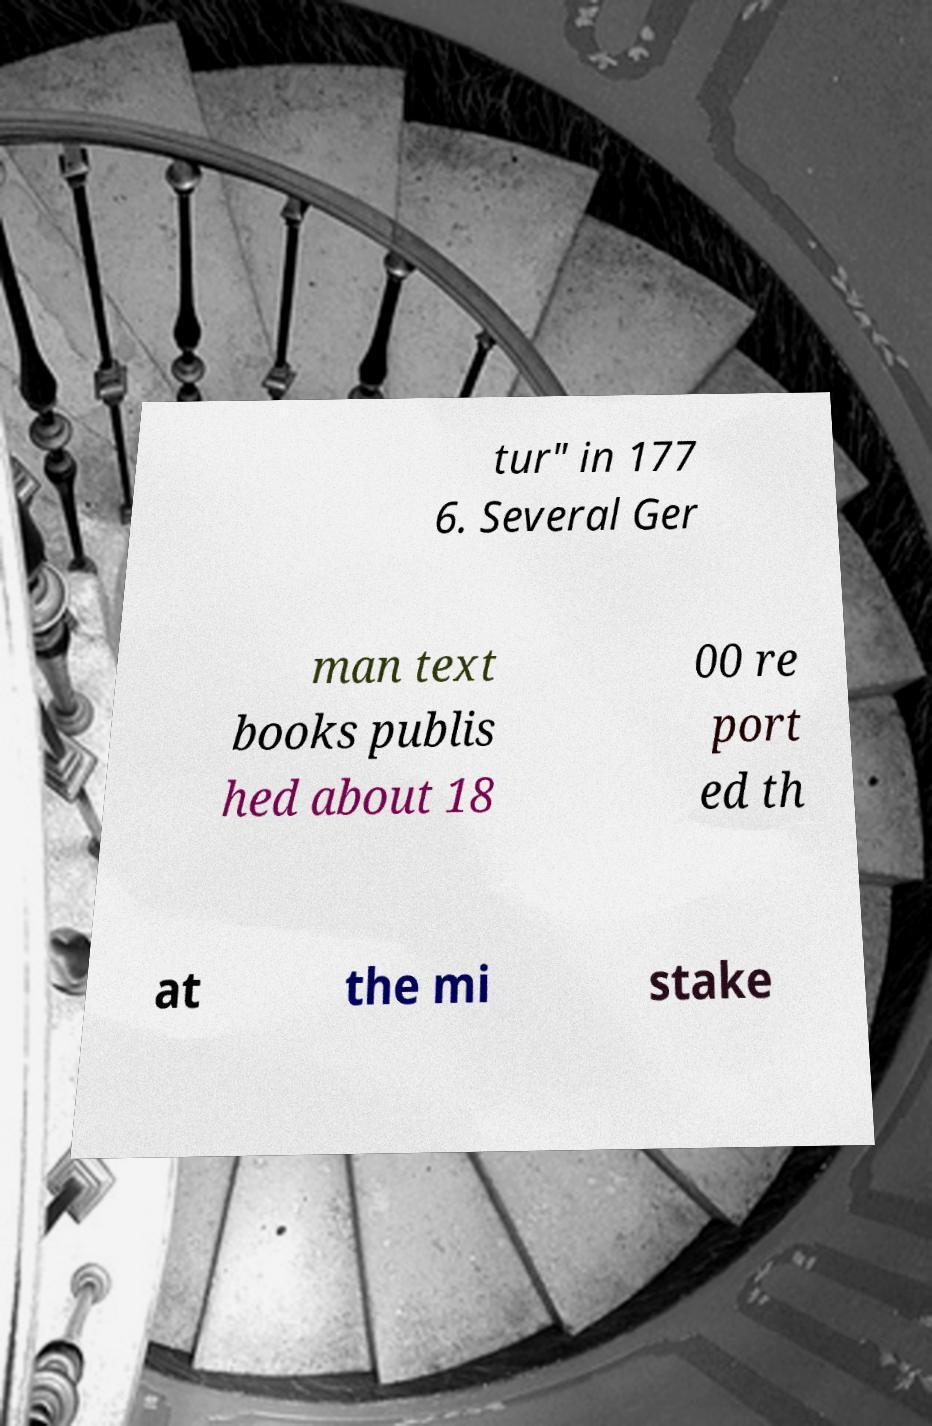What messages or text are displayed in this image? I need them in a readable, typed format. tur" in 177 6. Several Ger man text books publis hed about 18 00 re port ed th at the mi stake 